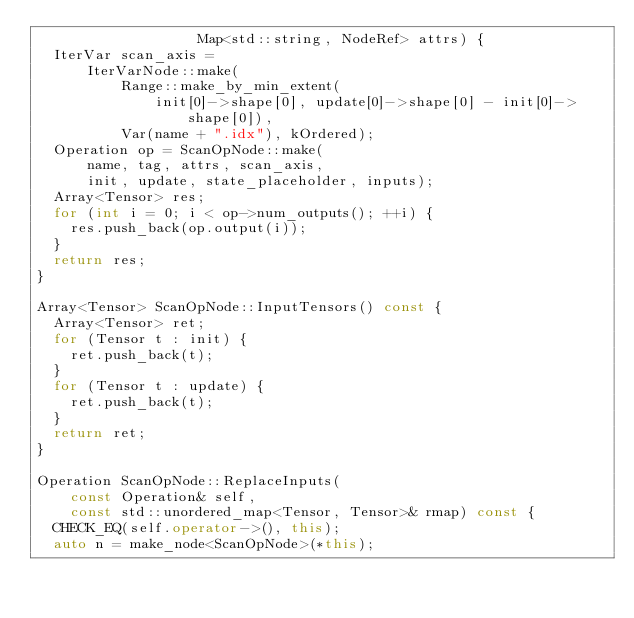Convert code to text. <code><loc_0><loc_0><loc_500><loc_500><_C++_>                   Map<std::string, NodeRef> attrs) {
  IterVar scan_axis =
      IterVarNode::make(
          Range::make_by_min_extent(
              init[0]->shape[0], update[0]->shape[0] - init[0]->shape[0]),
          Var(name + ".idx"), kOrdered);
  Operation op = ScanOpNode::make(
      name, tag, attrs, scan_axis,
      init, update, state_placeholder, inputs);
  Array<Tensor> res;
  for (int i = 0; i < op->num_outputs(); ++i) {
    res.push_back(op.output(i));
  }
  return res;
}

Array<Tensor> ScanOpNode::InputTensors() const {
  Array<Tensor> ret;
  for (Tensor t : init) {
    ret.push_back(t);
  }
  for (Tensor t : update) {
    ret.push_back(t);
  }
  return ret;
}

Operation ScanOpNode::ReplaceInputs(
    const Operation& self,
    const std::unordered_map<Tensor, Tensor>& rmap) const {
  CHECK_EQ(self.operator->(), this);
  auto n = make_node<ScanOpNode>(*this);</code> 